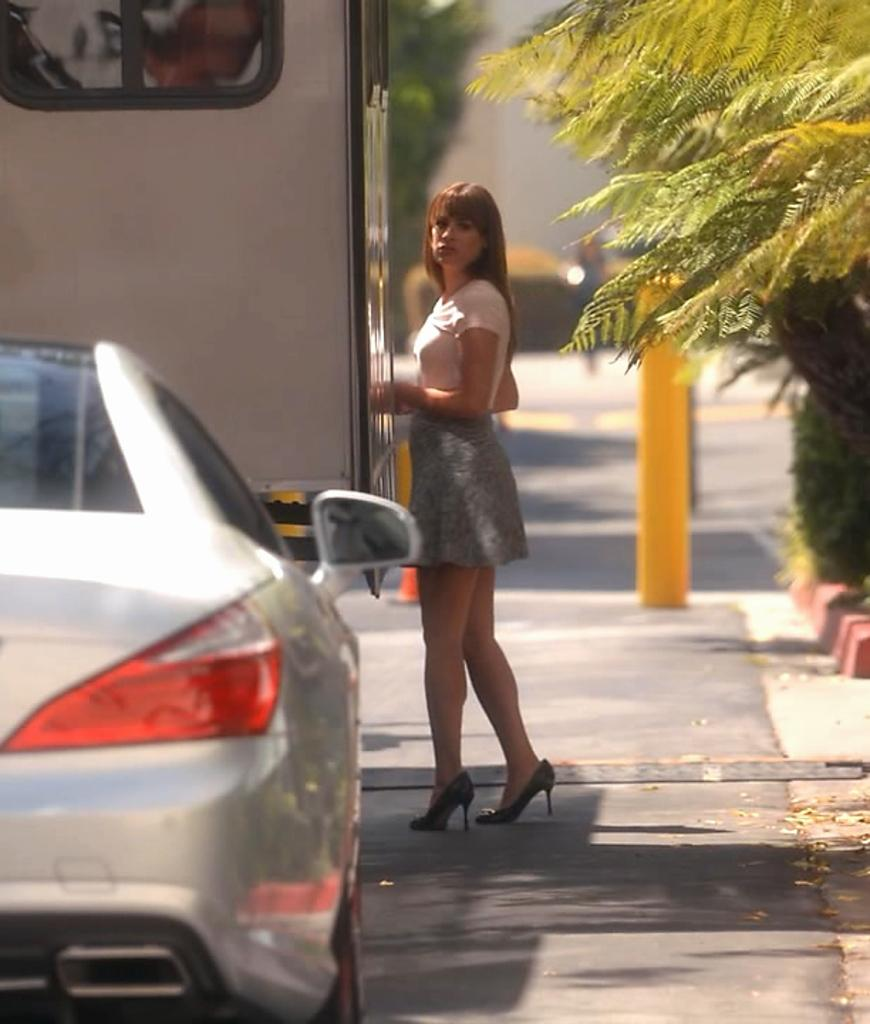Who is the main subject in the image? There is a lady in the center of the image. What can be seen in the background of the image? There is a pole in the background of the image. What is located on the right side of the image? There is a tree on the right side of the image. What is happening in the foreground of the image? There are vehicles on the road in the foreground of the image. What type of impulse can be seen affecting the lady in the image? There is no indication of any impulse affecting the lady in the image. What topic is being discussed by the lady in the image? There is no discussion taking place in the image, as the lady is the only person present. 